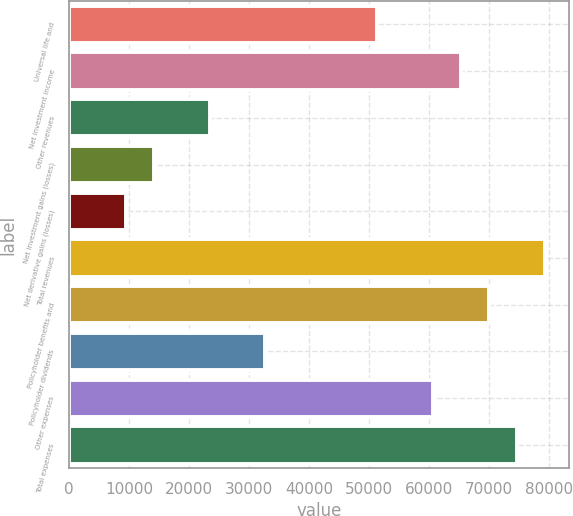Convert chart. <chart><loc_0><loc_0><loc_500><loc_500><bar_chart><fcel>Universal life and<fcel>Net investment income<fcel>Other revenues<fcel>Net investment gains (losses)<fcel>Net derivative gains (losses)<fcel>Total revenues<fcel>Policyholder benefits and<fcel>Policyholder dividends<fcel>Other expenses<fcel>Total expenses<nl><fcel>51417.9<fcel>65403.6<fcel>23446.5<fcel>14122.7<fcel>9460.8<fcel>79389.3<fcel>70065.5<fcel>32770.3<fcel>60741.7<fcel>74727.4<nl></chart> 